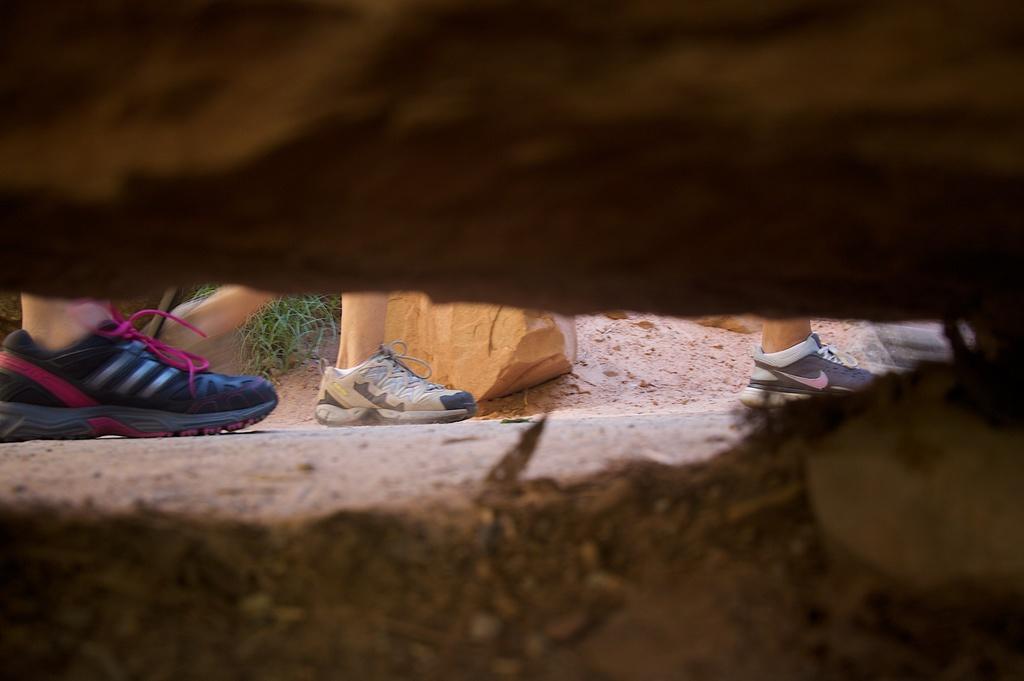Describe this image in one or two sentences. In this picture I can see few human legs and I can see a rock and a plant on the ground. 